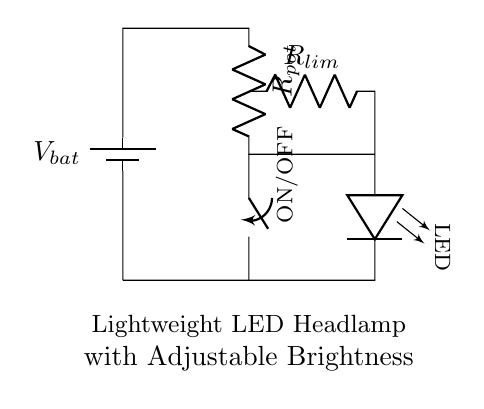What is the main power source in this circuit? The main power source is a battery, indicated as \( V_{bat} \) in the circuit diagram. This is where the circuit receives its power to operate.
Answer: battery What component is used to limit the current to the LED? The component that limits the current is the resistor labeled \( R_{lim} \). This resistor is connected in series with the LED to prevent excessive current that could damage it.
Answer: R limiting resistor How can the brightness of the LED be adjusted? The brightness of the LED can be adjusted via the potentiometer \( R_{pot} \). By changing its resistance, the current flowing to the LED can be varied, which in turn controls the brightness.
Answer: potentiometer What happens when the switch is turned ON? When the switch is turned ON, it closes the circuit, allowing current to flow from the battery through the circuit, powering the LED and allowing it to illuminated.
Answer: LED lights up What is the purpose of the resistor \( R_{lim} \) in this circuit? The purpose of \( R_{lim} \) is to limit the amount of current flowing to the LED, ensuring it operates safely within its rated specifications, preventing damage due to overcurrent.
Answer: current limit What is missing from the circuit that might be necessary for user safety? There is no fuse or additional protective component indicated in the circuit for safety against overcurrent conditions, which could be essential in protecting both the circuit and the user.
Answer: fuse 